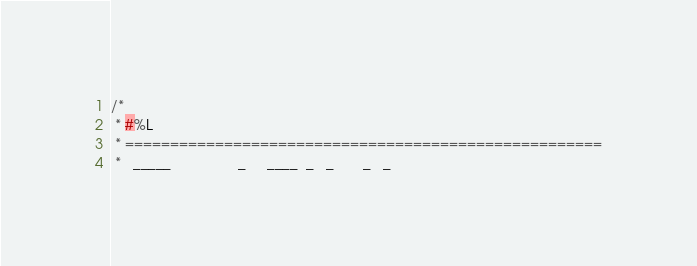<code> <loc_0><loc_0><loc_500><loc_500><_Java_>/*
 * #%L
 * =====================================================
 *   _____                _     ____  _   _       _   _</code> 